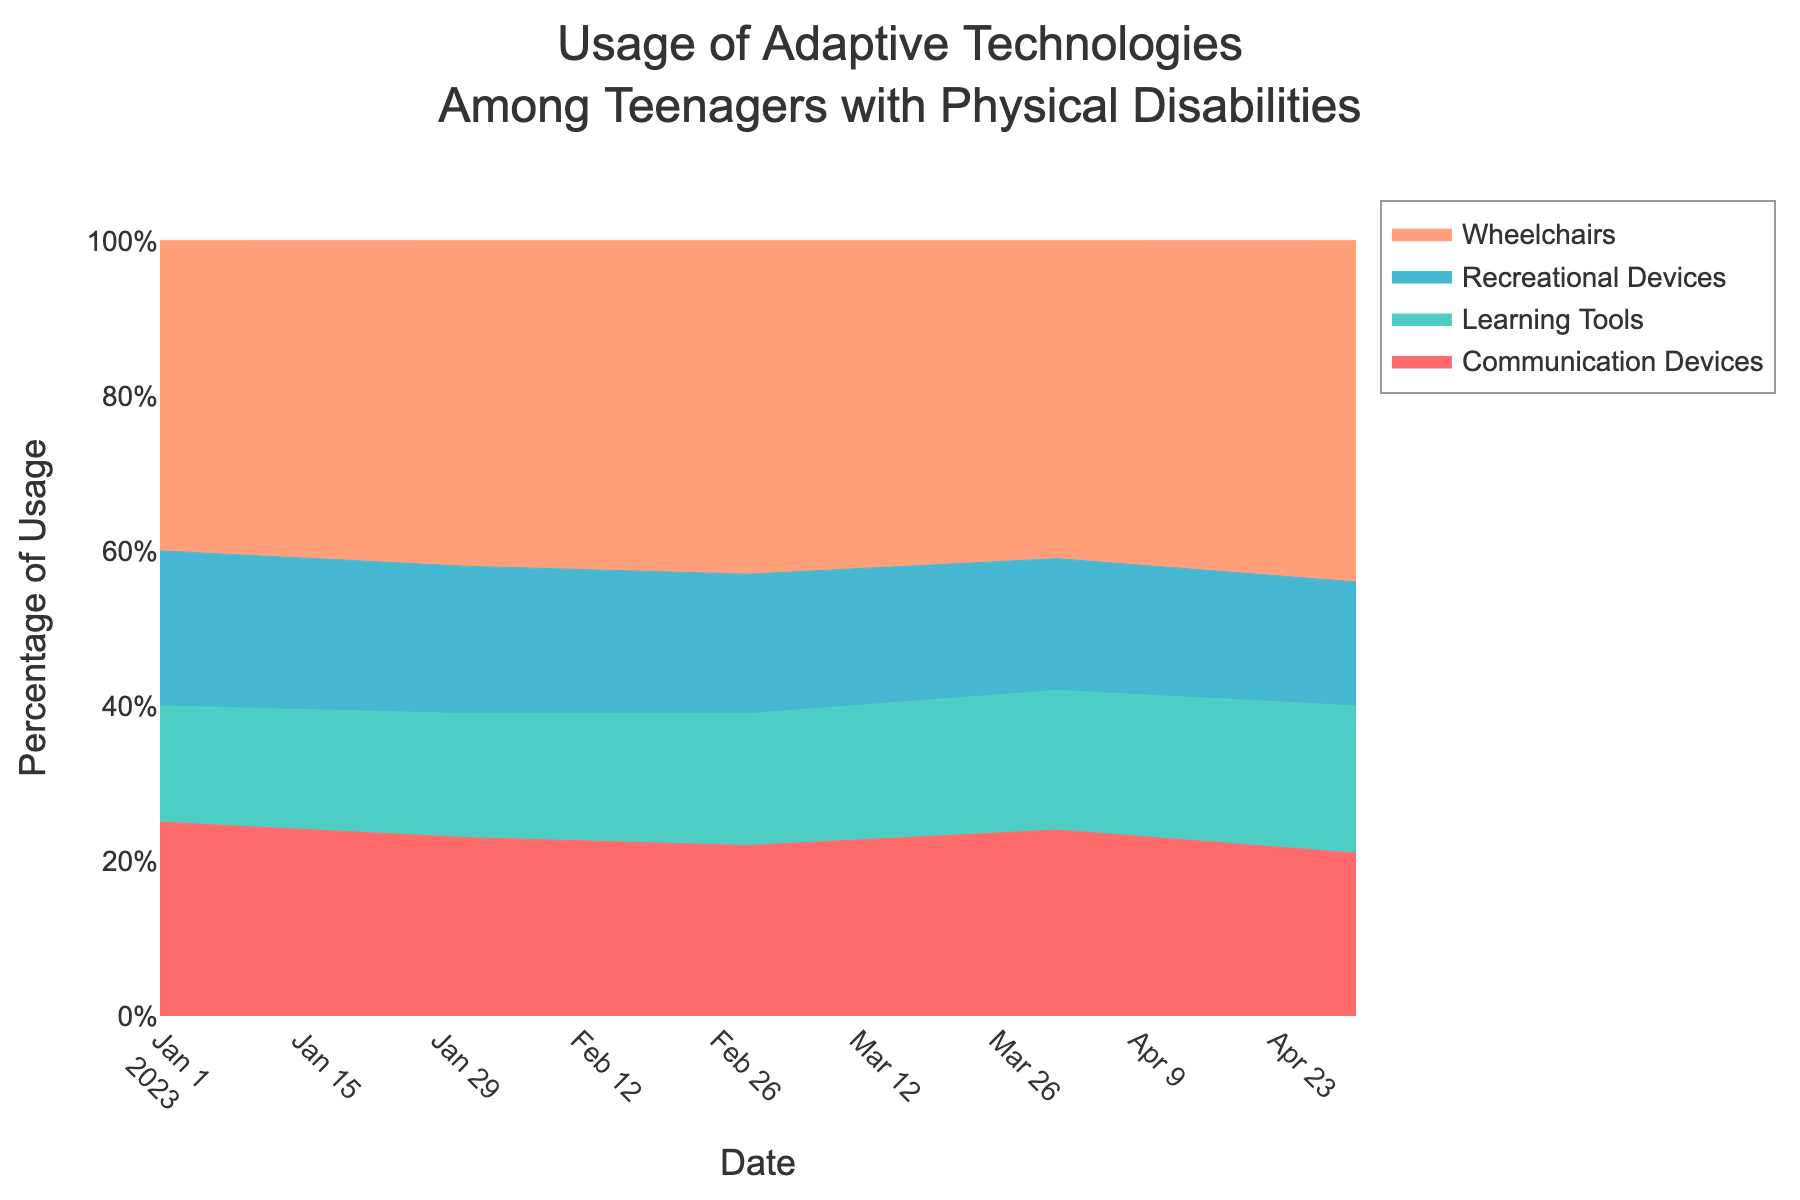what is the title of the figure? The title is typically located at the top of the figure and often written in larger or bold font.
Answer: Usage of Adaptive Technologies Among Teenagers with Physical Disabilities how many adaptive technologies are being compared? By looking at the legend or the different colored areas in the stacked area chart, one can count the number of categories.
Answer: Four what color represents communication devices? Based on the color legend or the colored area corresponding to 'Communication Devices' in the chart.
Answer: Light teal (greenish-blue) how does the percentage of wheelchair usage change from January to May 2023? Trace the area corresponding to wheelchairs from January to May, and note their beginning and ending percentages.
Answer: It increases from 40% to 44% which adaptive technology had the lowest usage in May 2023? Look at the smallest area at the point corresponding to May 2023.
Answer: Recreational Devices what is the overall trend for learning tools from January to May 2023? Follow the area corresponding to 'Learning Tools' across the months to observe if it is generally increasing or decreasing.
Answer: The trend is increasing did communication devices or recreational devices have higher usage in February 2023? Compare the height of the areas corresponding to 'Communication Devices' and 'Recreational Devices' at February 2023.
Answer: Communication Devices calculate the average usage of learning tools over these five months. Sum the percentages for learning tools over January to May and divide by 5 ((15+16+17+18+19)/5).
Answer: 17% which technology saw a decrease in usage from April to May 2023? Follow the areas from April to May and find the one that becomes smaller.
Answer: Communication Devices are wheelchairs always the most used technology throughout the period? Check if the area corresponding to 'Wheelchairs' is always the tallest across all months.
Answer: Yes 